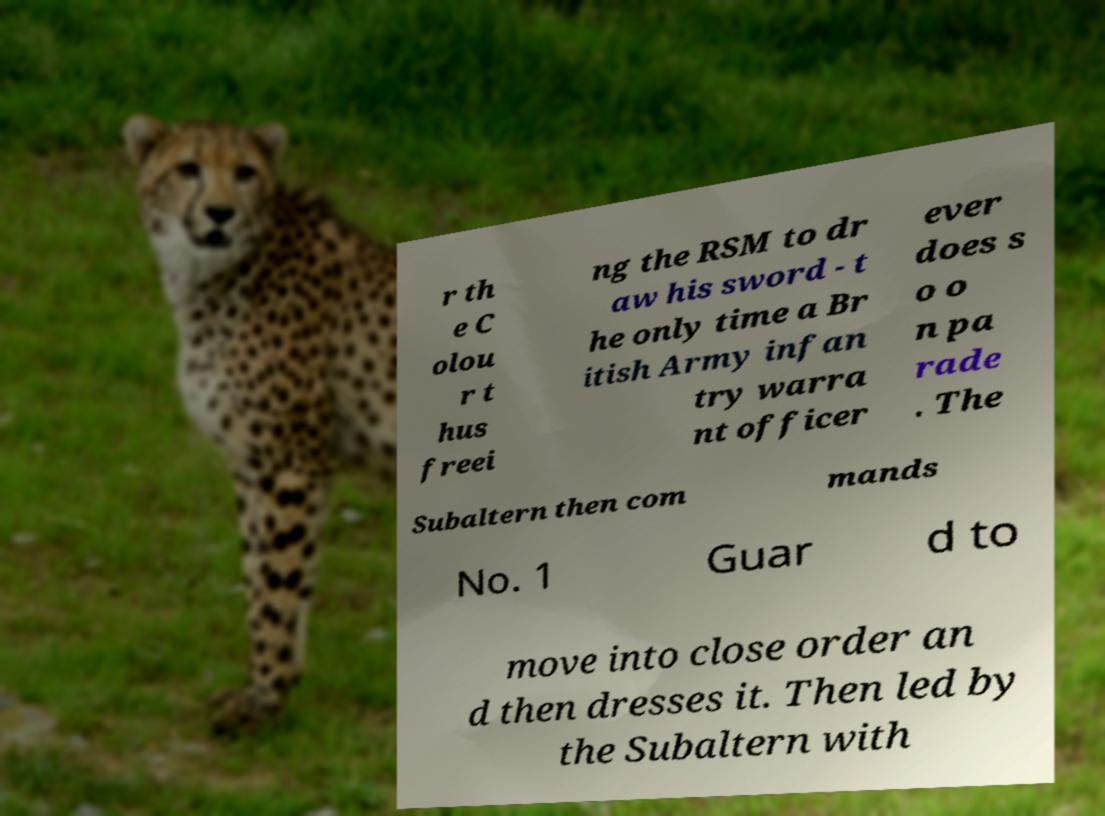Could you assist in decoding the text presented in this image and type it out clearly? r th e C olou r t hus freei ng the RSM to dr aw his sword - t he only time a Br itish Army infan try warra nt officer ever does s o o n pa rade . The Subaltern then com mands No. 1 Guar d to move into close order an d then dresses it. Then led by the Subaltern with 